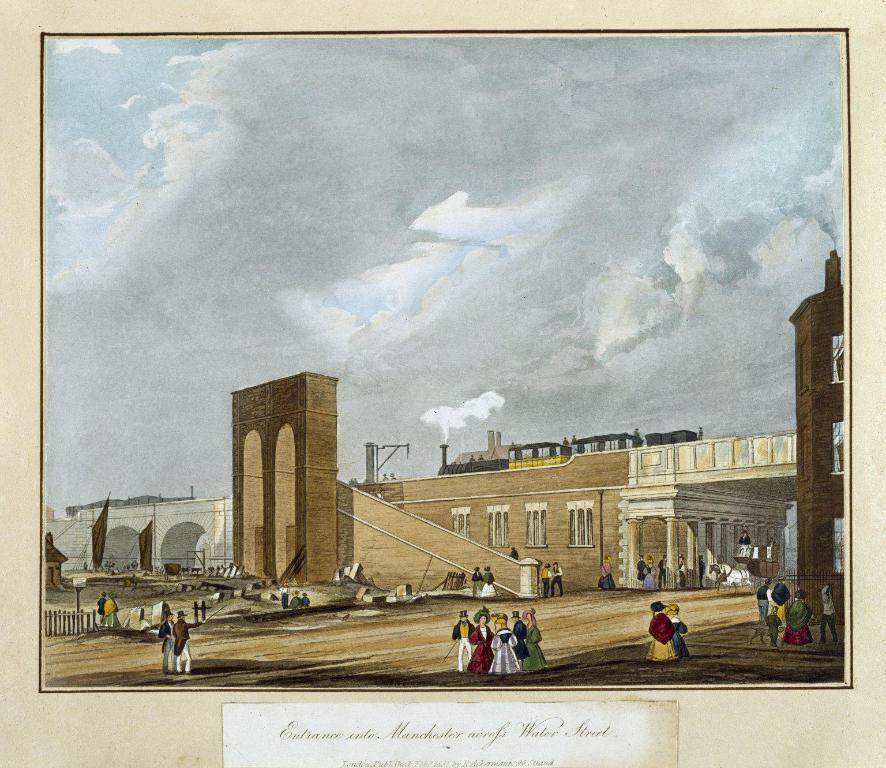In one or two sentences, can you explain what this image depicts? This looks like a painting. I can see groups of people standing. This is the building with windows and pillars. I think this is the train. This looks like an arch. I can see the wooden fence. This looks like a pillar. This is the sky. I can see the letters in the image. 